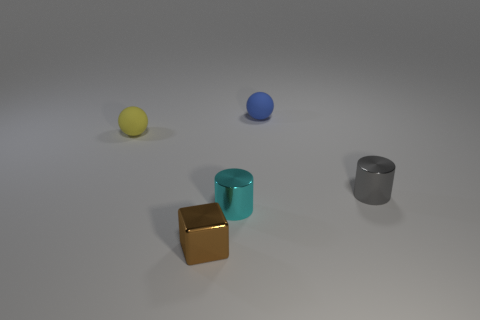Are the brown cube and the gray thing made of the same material?
Your answer should be very brief. Yes. How many balls are either tiny shiny objects or tiny yellow objects?
Offer a very short reply. 1. There is a cyan thing that is the same shape as the gray metal object; what is its size?
Keep it short and to the point. Small. What number of blue rubber balls are to the left of the blue ball?
Your answer should be compact. 0. What number of green objects are tiny matte balls or metal cylinders?
Give a very brief answer. 0. What color is the tiny ball that is on the left side of the thing that is in front of the small cyan thing?
Your response must be concise. Yellow. There is a small shiny cylinder on the left side of the blue thing; what color is it?
Offer a terse response. Cyan. Does the matte ball that is right of the yellow rubber object have the same size as the small gray metal cylinder?
Your answer should be compact. Yes. Is there a shiny block that has the same size as the cyan cylinder?
Ensure brevity in your answer.  Yes. There is a object that is behind the yellow thing; does it have the same color as the small metal thing that is behind the tiny cyan metal thing?
Keep it short and to the point. No. 